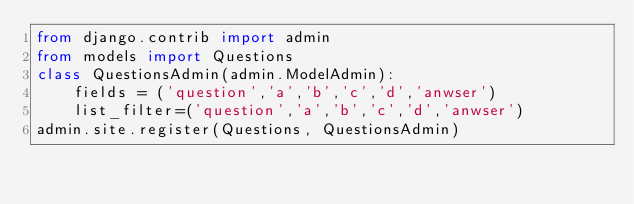Convert code to text. <code><loc_0><loc_0><loc_500><loc_500><_Python_>from django.contrib import admin
from models import Questions
class QuestionsAdmin(admin.ModelAdmin):
    fields = ('question','a','b','c','d','anwser')
    list_filter=('question','a','b','c','d','anwser')
admin.site.register(Questions, QuestionsAdmin)</code> 